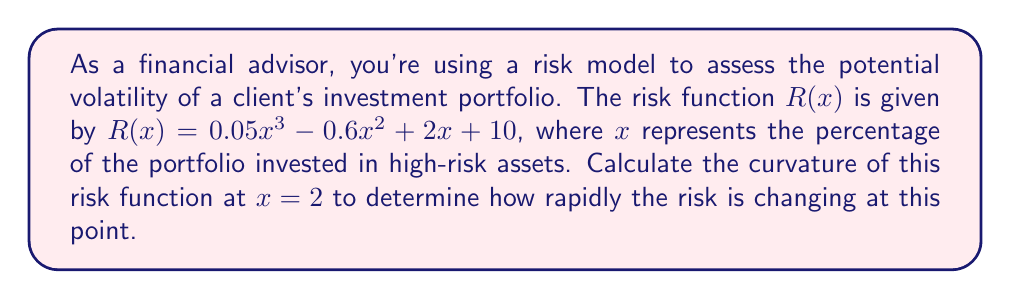Teach me how to tackle this problem. To analyze the curvature of the risk function, we need to calculate its second derivative and evaluate it at the given point. The curvature is then given by the formula:

$$\kappa = \frac{|R''(x)|}{(1 + (R'(x))^2)^{3/2}}$$

Step 1: Calculate the first derivative of $R(x)$
$$R'(x) = 0.15x^2 - 1.2x + 2$$

Step 2: Calculate the second derivative of $R(x)$
$$R''(x) = 0.3x - 1.2$$

Step 3: Evaluate $R'(x)$ and $R''(x)$ at $x = 2$
$$R'(2) = 0.15(2)^2 - 1.2(2) + 2 = 0.6 - 2.4 + 2 = 0.2$$
$$R''(2) = 0.3(2) - 1.2 = 0.6 - 1.2 = -0.6$$

Step 4: Apply the curvature formula
$$\kappa = \frac{|R''(2)|}{(1 + (R'(2))^2)^{3/2}}$$
$$\kappa = \frac{|-0.6|}{(1 + (0.2)^2)^{3/2}}$$
$$\kappa = \frac{0.6}{(1 + 0.04)^{3/2}}$$
$$\kappa = \frac{0.6}{(1.04)^{3/2}}$$
$$\kappa \approx 0.5769$$

The curvature at $x = 2$ is approximately 0.5769, indicating a moderate rate of change in the risk function at this point.
Answer: The curvature of the risk function at $x = 2$ is approximately 0.5769. 